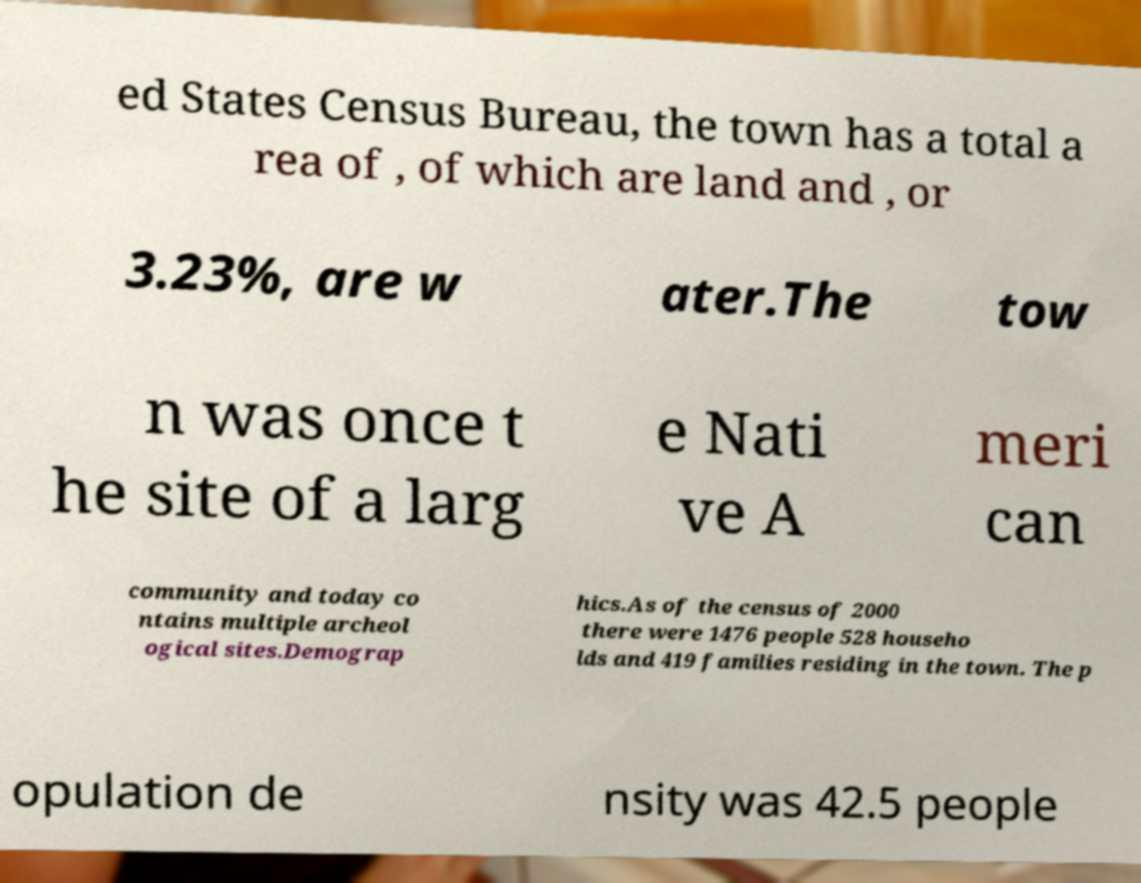There's text embedded in this image that I need extracted. Can you transcribe it verbatim? ed States Census Bureau, the town has a total a rea of , of which are land and , or 3.23%, are w ater.The tow n was once t he site of a larg e Nati ve A meri can community and today co ntains multiple archeol ogical sites.Demograp hics.As of the census of 2000 there were 1476 people 528 househo lds and 419 families residing in the town. The p opulation de nsity was 42.5 people 